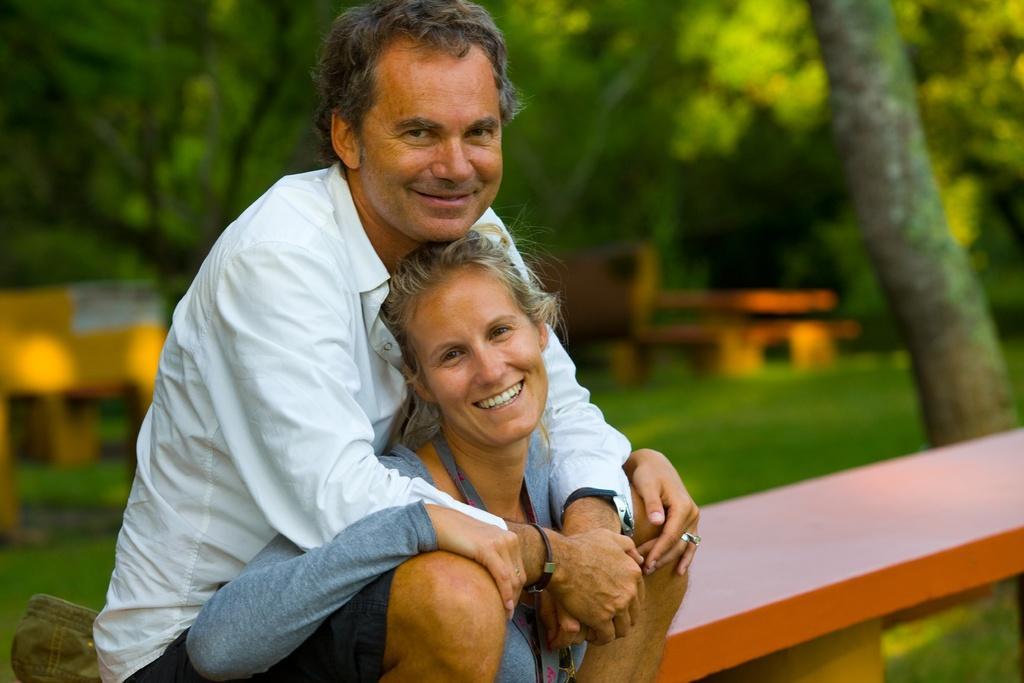Could you give a brief overview of what you see in this image? Here I can see a woman and a man sitting on a bench, smiling and giving pose for the picture. The man is wearing white color shirt and women is wearing a t-shirt. In the background, I can see some trees and benches. On the right side there is a tree trunk. At the bottom of the image I can see the grass in green color. 